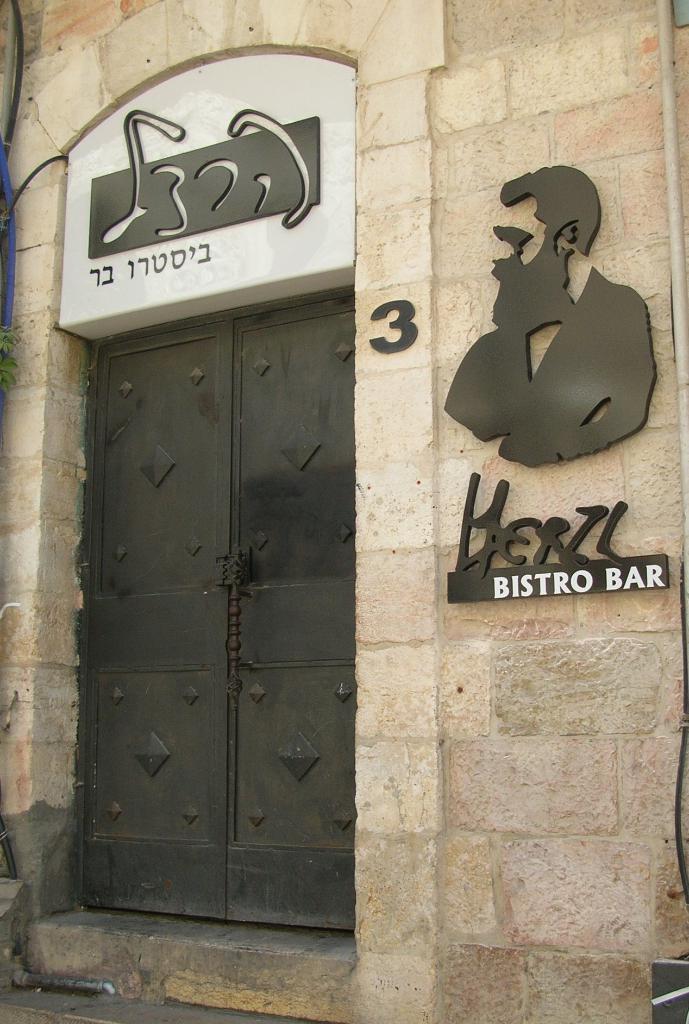In one or two sentences, can you explain what this image depicts? In this image there is a wall. At the bottom there is a door to the wall. On the right side there is a design of a man on the wall. 